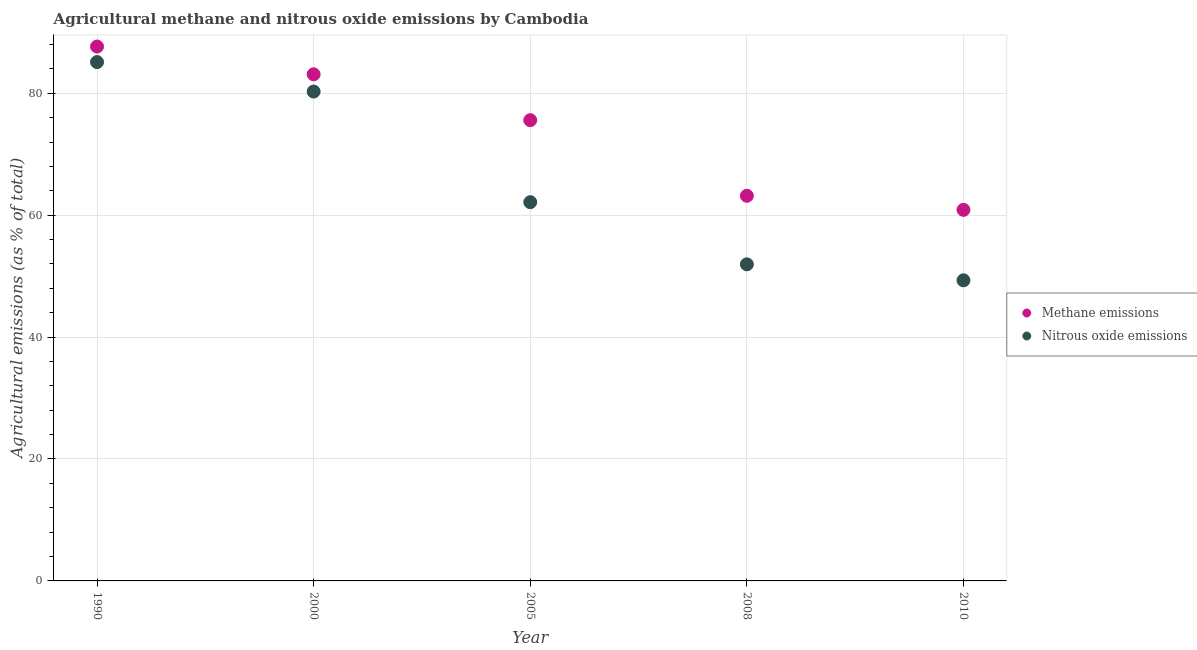What is the amount of methane emissions in 2000?
Your response must be concise. 83.11. Across all years, what is the maximum amount of nitrous oxide emissions?
Your response must be concise. 85.11. Across all years, what is the minimum amount of nitrous oxide emissions?
Your answer should be very brief. 49.31. In which year was the amount of methane emissions maximum?
Your answer should be very brief. 1990. In which year was the amount of methane emissions minimum?
Provide a succinct answer. 2010. What is the total amount of nitrous oxide emissions in the graph?
Keep it short and to the point. 328.76. What is the difference between the amount of methane emissions in 1990 and that in 2010?
Offer a terse response. 26.79. What is the difference between the amount of nitrous oxide emissions in 1990 and the amount of methane emissions in 2008?
Provide a short and direct response. 21.93. What is the average amount of methane emissions per year?
Provide a short and direct response. 74.08. In the year 2005, what is the difference between the amount of methane emissions and amount of nitrous oxide emissions?
Your answer should be very brief. 13.45. In how many years, is the amount of nitrous oxide emissions greater than 44 %?
Ensure brevity in your answer.  5. What is the ratio of the amount of methane emissions in 1990 to that in 2008?
Ensure brevity in your answer.  1.39. Is the amount of methane emissions in 2000 less than that in 2008?
Your response must be concise. No. Is the difference between the amount of methane emissions in 1990 and 2000 greater than the difference between the amount of nitrous oxide emissions in 1990 and 2000?
Keep it short and to the point. No. What is the difference between the highest and the second highest amount of nitrous oxide emissions?
Keep it short and to the point. 4.83. What is the difference between the highest and the lowest amount of methane emissions?
Keep it short and to the point. 26.79. In how many years, is the amount of methane emissions greater than the average amount of methane emissions taken over all years?
Your answer should be compact. 3. Is the sum of the amount of methane emissions in 1990 and 2000 greater than the maximum amount of nitrous oxide emissions across all years?
Provide a short and direct response. Yes. Does the amount of methane emissions monotonically increase over the years?
Offer a very short reply. No. How many years are there in the graph?
Your answer should be very brief. 5. What is the difference between two consecutive major ticks on the Y-axis?
Make the answer very short. 20. Does the graph contain any zero values?
Give a very brief answer. No. Does the graph contain grids?
Provide a short and direct response. Yes. What is the title of the graph?
Ensure brevity in your answer.  Agricultural methane and nitrous oxide emissions by Cambodia. What is the label or title of the X-axis?
Offer a terse response. Year. What is the label or title of the Y-axis?
Your answer should be very brief. Agricultural emissions (as % of total). What is the Agricultural emissions (as % of total) of Methane emissions in 1990?
Provide a short and direct response. 87.66. What is the Agricultural emissions (as % of total) of Nitrous oxide emissions in 1990?
Offer a very short reply. 85.11. What is the Agricultural emissions (as % of total) of Methane emissions in 2000?
Ensure brevity in your answer.  83.11. What is the Agricultural emissions (as % of total) in Nitrous oxide emissions in 2000?
Provide a short and direct response. 80.27. What is the Agricultural emissions (as % of total) in Methane emissions in 2005?
Your answer should be compact. 75.58. What is the Agricultural emissions (as % of total) in Nitrous oxide emissions in 2005?
Your answer should be compact. 62.13. What is the Agricultural emissions (as % of total) of Methane emissions in 2008?
Your answer should be very brief. 63.18. What is the Agricultural emissions (as % of total) in Nitrous oxide emissions in 2008?
Ensure brevity in your answer.  51.93. What is the Agricultural emissions (as % of total) of Methane emissions in 2010?
Make the answer very short. 60.87. What is the Agricultural emissions (as % of total) of Nitrous oxide emissions in 2010?
Provide a short and direct response. 49.31. Across all years, what is the maximum Agricultural emissions (as % of total) of Methane emissions?
Offer a very short reply. 87.66. Across all years, what is the maximum Agricultural emissions (as % of total) in Nitrous oxide emissions?
Give a very brief answer. 85.11. Across all years, what is the minimum Agricultural emissions (as % of total) of Methane emissions?
Provide a succinct answer. 60.87. Across all years, what is the minimum Agricultural emissions (as % of total) of Nitrous oxide emissions?
Give a very brief answer. 49.31. What is the total Agricultural emissions (as % of total) of Methane emissions in the graph?
Your answer should be very brief. 370.39. What is the total Agricultural emissions (as % of total) in Nitrous oxide emissions in the graph?
Your response must be concise. 328.76. What is the difference between the Agricultural emissions (as % of total) of Methane emissions in 1990 and that in 2000?
Your answer should be compact. 4.55. What is the difference between the Agricultural emissions (as % of total) of Nitrous oxide emissions in 1990 and that in 2000?
Your response must be concise. 4.83. What is the difference between the Agricultural emissions (as % of total) of Methane emissions in 1990 and that in 2005?
Provide a short and direct response. 12.07. What is the difference between the Agricultural emissions (as % of total) of Nitrous oxide emissions in 1990 and that in 2005?
Offer a terse response. 22.98. What is the difference between the Agricultural emissions (as % of total) of Methane emissions in 1990 and that in 2008?
Your answer should be very brief. 24.48. What is the difference between the Agricultural emissions (as % of total) in Nitrous oxide emissions in 1990 and that in 2008?
Provide a short and direct response. 33.18. What is the difference between the Agricultural emissions (as % of total) in Methane emissions in 1990 and that in 2010?
Offer a very short reply. 26.79. What is the difference between the Agricultural emissions (as % of total) of Nitrous oxide emissions in 1990 and that in 2010?
Give a very brief answer. 35.8. What is the difference between the Agricultural emissions (as % of total) in Methane emissions in 2000 and that in 2005?
Give a very brief answer. 7.52. What is the difference between the Agricultural emissions (as % of total) of Nitrous oxide emissions in 2000 and that in 2005?
Provide a short and direct response. 18.14. What is the difference between the Agricultural emissions (as % of total) in Methane emissions in 2000 and that in 2008?
Provide a short and direct response. 19.93. What is the difference between the Agricultural emissions (as % of total) of Nitrous oxide emissions in 2000 and that in 2008?
Provide a short and direct response. 28.34. What is the difference between the Agricultural emissions (as % of total) in Methane emissions in 2000 and that in 2010?
Your response must be concise. 22.24. What is the difference between the Agricultural emissions (as % of total) of Nitrous oxide emissions in 2000 and that in 2010?
Make the answer very short. 30.96. What is the difference between the Agricultural emissions (as % of total) in Methane emissions in 2005 and that in 2008?
Ensure brevity in your answer.  12.41. What is the difference between the Agricultural emissions (as % of total) of Nitrous oxide emissions in 2005 and that in 2008?
Offer a terse response. 10.2. What is the difference between the Agricultural emissions (as % of total) in Methane emissions in 2005 and that in 2010?
Offer a very short reply. 14.71. What is the difference between the Agricultural emissions (as % of total) in Nitrous oxide emissions in 2005 and that in 2010?
Provide a short and direct response. 12.82. What is the difference between the Agricultural emissions (as % of total) in Methane emissions in 2008 and that in 2010?
Provide a succinct answer. 2.31. What is the difference between the Agricultural emissions (as % of total) in Nitrous oxide emissions in 2008 and that in 2010?
Ensure brevity in your answer.  2.62. What is the difference between the Agricultural emissions (as % of total) of Methane emissions in 1990 and the Agricultural emissions (as % of total) of Nitrous oxide emissions in 2000?
Make the answer very short. 7.38. What is the difference between the Agricultural emissions (as % of total) in Methane emissions in 1990 and the Agricultural emissions (as % of total) in Nitrous oxide emissions in 2005?
Give a very brief answer. 25.52. What is the difference between the Agricultural emissions (as % of total) in Methane emissions in 1990 and the Agricultural emissions (as % of total) in Nitrous oxide emissions in 2008?
Provide a succinct answer. 35.72. What is the difference between the Agricultural emissions (as % of total) of Methane emissions in 1990 and the Agricultural emissions (as % of total) of Nitrous oxide emissions in 2010?
Provide a succinct answer. 38.34. What is the difference between the Agricultural emissions (as % of total) of Methane emissions in 2000 and the Agricultural emissions (as % of total) of Nitrous oxide emissions in 2005?
Ensure brevity in your answer.  20.97. What is the difference between the Agricultural emissions (as % of total) of Methane emissions in 2000 and the Agricultural emissions (as % of total) of Nitrous oxide emissions in 2008?
Give a very brief answer. 31.17. What is the difference between the Agricultural emissions (as % of total) in Methane emissions in 2000 and the Agricultural emissions (as % of total) in Nitrous oxide emissions in 2010?
Provide a succinct answer. 33.79. What is the difference between the Agricultural emissions (as % of total) of Methane emissions in 2005 and the Agricultural emissions (as % of total) of Nitrous oxide emissions in 2008?
Offer a very short reply. 23.65. What is the difference between the Agricultural emissions (as % of total) in Methane emissions in 2005 and the Agricultural emissions (as % of total) in Nitrous oxide emissions in 2010?
Provide a short and direct response. 26.27. What is the difference between the Agricultural emissions (as % of total) in Methane emissions in 2008 and the Agricultural emissions (as % of total) in Nitrous oxide emissions in 2010?
Your response must be concise. 13.86. What is the average Agricultural emissions (as % of total) in Methane emissions per year?
Give a very brief answer. 74.08. What is the average Agricultural emissions (as % of total) in Nitrous oxide emissions per year?
Make the answer very short. 65.75. In the year 1990, what is the difference between the Agricultural emissions (as % of total) in Methane emissions and Agricultural emissions (as % of total) in Nitrous oxide emissions?
Offer a terse response. 2.55. In the year 2000, what is the difference between the Agricultural emissions (as % of total) of Methane emissions and Agricultural emissions (as % of total) of Nitrous oxide emissions?
Ensure brevity in your answer.  2.83. In the year 2005, what is the difference between the Agricultural emissions (as % of total) in Methane emissions and Agricultural emissions (as % of total) in Nitrous oxide emissions?
Give a very brief answer. 13.45. In the year 2008, what is the difference between the Agricultural emissions (as % of total) of Methane emissions and Agricultural emissions (as % of total) of Nitrous oxide emissions?
Keep it short and to the point. 11.24. In the year 2010, what is the difference between the Agricultural emissions (as % of total) in Methane emissions and Agricultural emissions (as % of total) in Nitrous oxide emissions?
Provide a short and direct response. 11.56. What is the ratio of the Agricultural emissions (as % of total) in Methane emissions in 1990 to that in 2000?
Offer a very short reply. 1.05. What is the ratio of the Agricultural emissions (as % of total) in Nitrous oxide emissions in 1990 to that in 2000?
Provide a succinct answer. 1.06. What is the ratio of the Agricultural emissions (as % of total) in Methane emissions in 1990 to that in 2005?
Keep it short and to the point. 1.16. What is the ratio of the Agricultural emissions (as % of total) of Nitrous oxide emissions in 1990 to that in 2005?
Provide a succinct answer. 1.37. What is the ratio of the Agricultural emissions (as % of total) in Methane emissions in 1990 to that in 2008?
Give a very brief answer. 1.39. What is the ratio of the Agricultural emissions (as % of total) in Nitrous oxide emissions in 1990 to that in 2008?
Your answer should be very brief. 1.64. What is the ratio of the Agricultural emissions (as % of total) in Methane emissions in 1990 to that in 2010?
Your answer should be compact. 1.44. What is the ratio of the Agricultural emissions (as % of total) in Nitrous oxide emissions in 1990 to that in 2010?
Provide a succinct answer. 1.73. What is the ratio of the Agricultural emissions (as % of total) in Methane emissions in 2000 to that in 2005?
Ensure brevity in your answer.  1.1. What is the ratio of the Agricultural emissions (as % of total) in Nitrous oxide emissions in 2000 to that in 2005?
Offer a very short reply. 1.29. What is the ratio of the Agricultural emissions (as % of total) of Methane emissions in 2000 to that in 2008?
Your answer should be compact. 1.32. What is the ratio of the Agricultural emissions (as % of total) of Nitrous oxide emissions in 2000 to that in 2008?
Ensure brevity in your answer.  1.55. What is the ratio of the Agricultural emissions (as % of total) in Methane emissions in 2000 to that in 2010?
Provide a short and direct response. 1.37. What is the ratio of the Agricultural emissions (as % of total) in Nitrous oxide emissions in 2000 to that in 2010?
Your answer should be very brief. 1.63. What is the ratio of the Agricultural emissions (as % of total) in Methane emissions in 2005 to that in 2008?
Provide a short and direct response. 1.2. What is the ratio of the Agricultural emissions (as % of total) in Nitrous oxide emissions in 2005 to that in 2008?
Your response must be concise. 1.2. What is the ratio of the Agricultural emissions (as % of total) of Methane emissions in 2005 to that in 2010?
Ensure brevity in your answer.  1.24. What is the ratio of the Agricultural emissions (as % of total) in Nitrous oxide emissions in 2005 to that in 2010?
Your answer should be compact. 1.26. What is the ratio of the Agricultural emissions (as % of total) in Methane emissions in 2008 to that in 2010?
Make the answer very short. 1.04. What is the ratio of the Agricultural emissions (as % of total) in Nitrous oxide emissions in 2008 to that in 2010?
Give a very brief answer. 1.05. What is the difference between the highest and the second highest Agricultural emissions (as % of total) of Methane emissions?
Make the answer very short. 4.55. What is the difference between the highest and the second highest Agricultural emissions (as % of total) in Nitrous oxide emissions?
Make the answer very short. 4.83. What is the difference between the highest and the lowest Agricultural emissions (as % of total) of Methane emissions?
Make the answer very short. 26.79. What is the difference between the highest and the lowest Agricultural emissions (as % of total) of Nitrous oxide emissions?
Your answer should be compact. 35.8. 